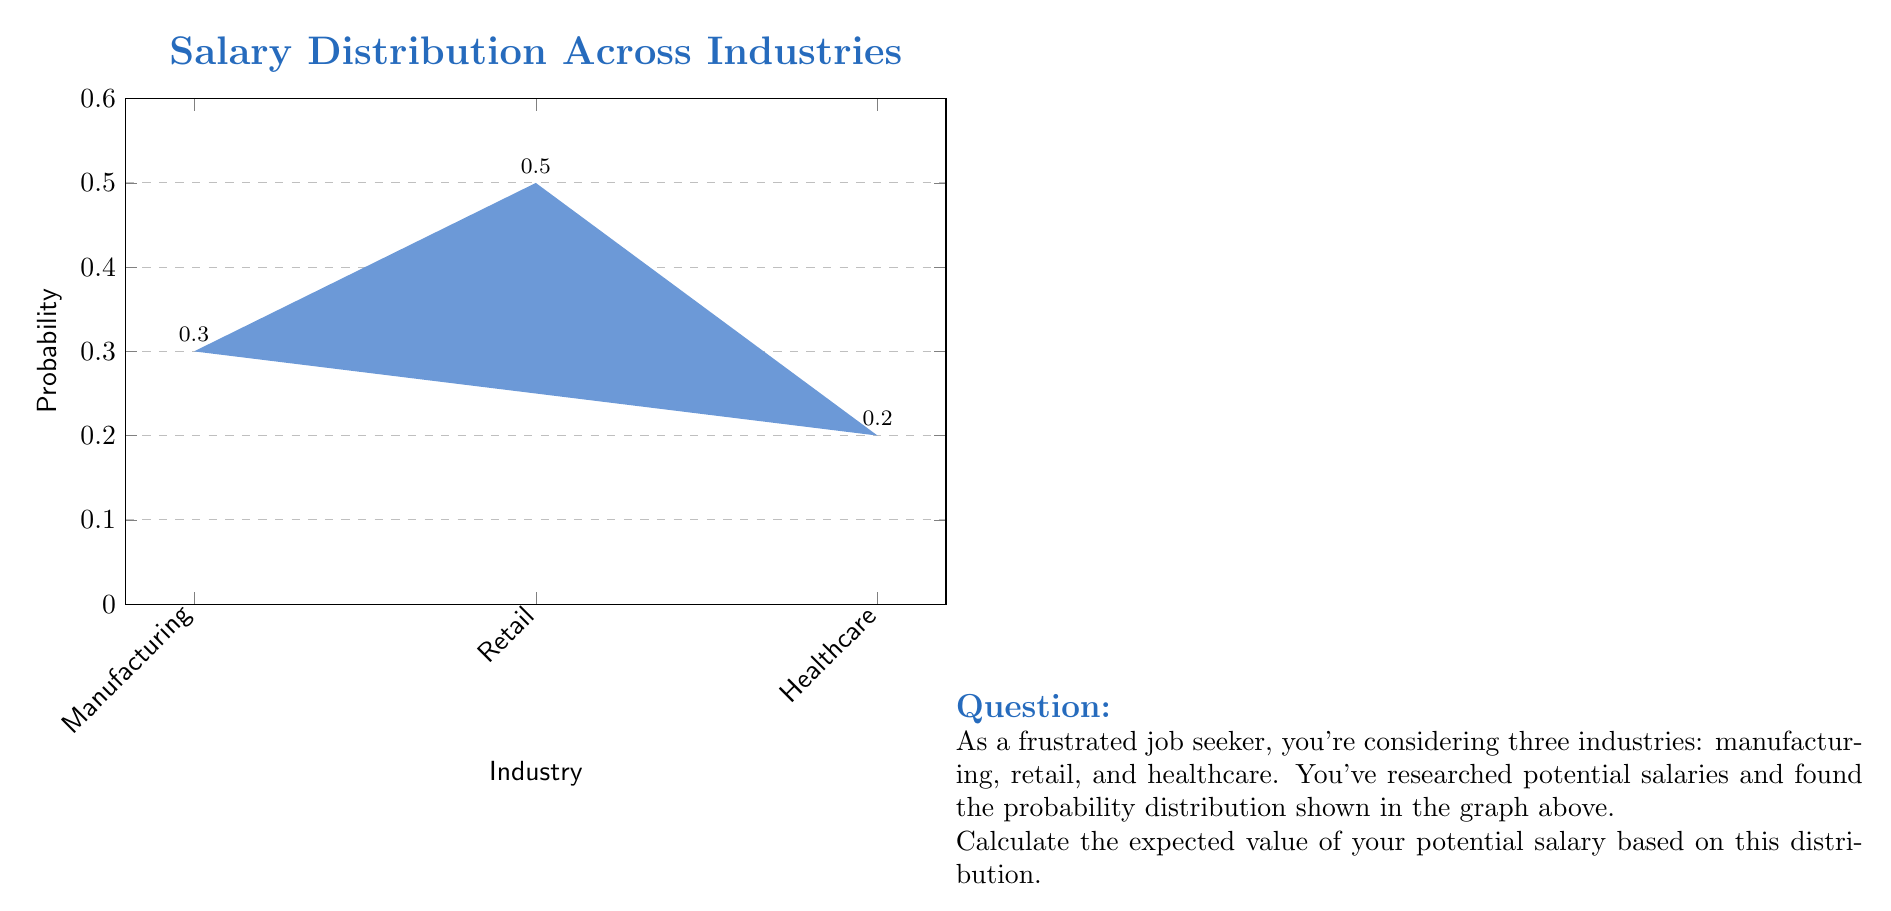Can you answer this question? To calculate the expected value, we need to multiply each possible outcome (salary) by its probability and then sum these products. Let's break it down step-by-step:

1) For Manufacturing:
   Probability = 0.3
   Salary = $35,000
   Expected value contribution = $35,000 × 0.3 = $10,500

2) For Retail:
   Probability = 0.5
   Salary = $28,000
   Expected value contribution = $28,000 × 0.5 = $14,000

3) For Healthcare:
   Probability = 0.2
   Salary = $42,000
   Expected value contribution = $42,000 × 0.2 = $8,400

4) Now, we sum these contributions:

   $$ E(\text{Salary}) = 10,500 + 14,000 + 8,400 = 32,900 $$

Therefore, the expected value of the potential salary is $32,900.

We can also express this calculation using the expected value formula:

$$ E(X) = \sum_{i=1}^{n} x_i \cdot p(x_i) $$

Where $x_i$ are the possible salaries and $p(x_i)$ are their respective probabilities.

$$ E(\text{Salary}) = 35000 \cdot 0.3 + 28000 \cdot 0.5 + 42000 \cdot 0.2 = 32,900 $$
Answer: $32,900 